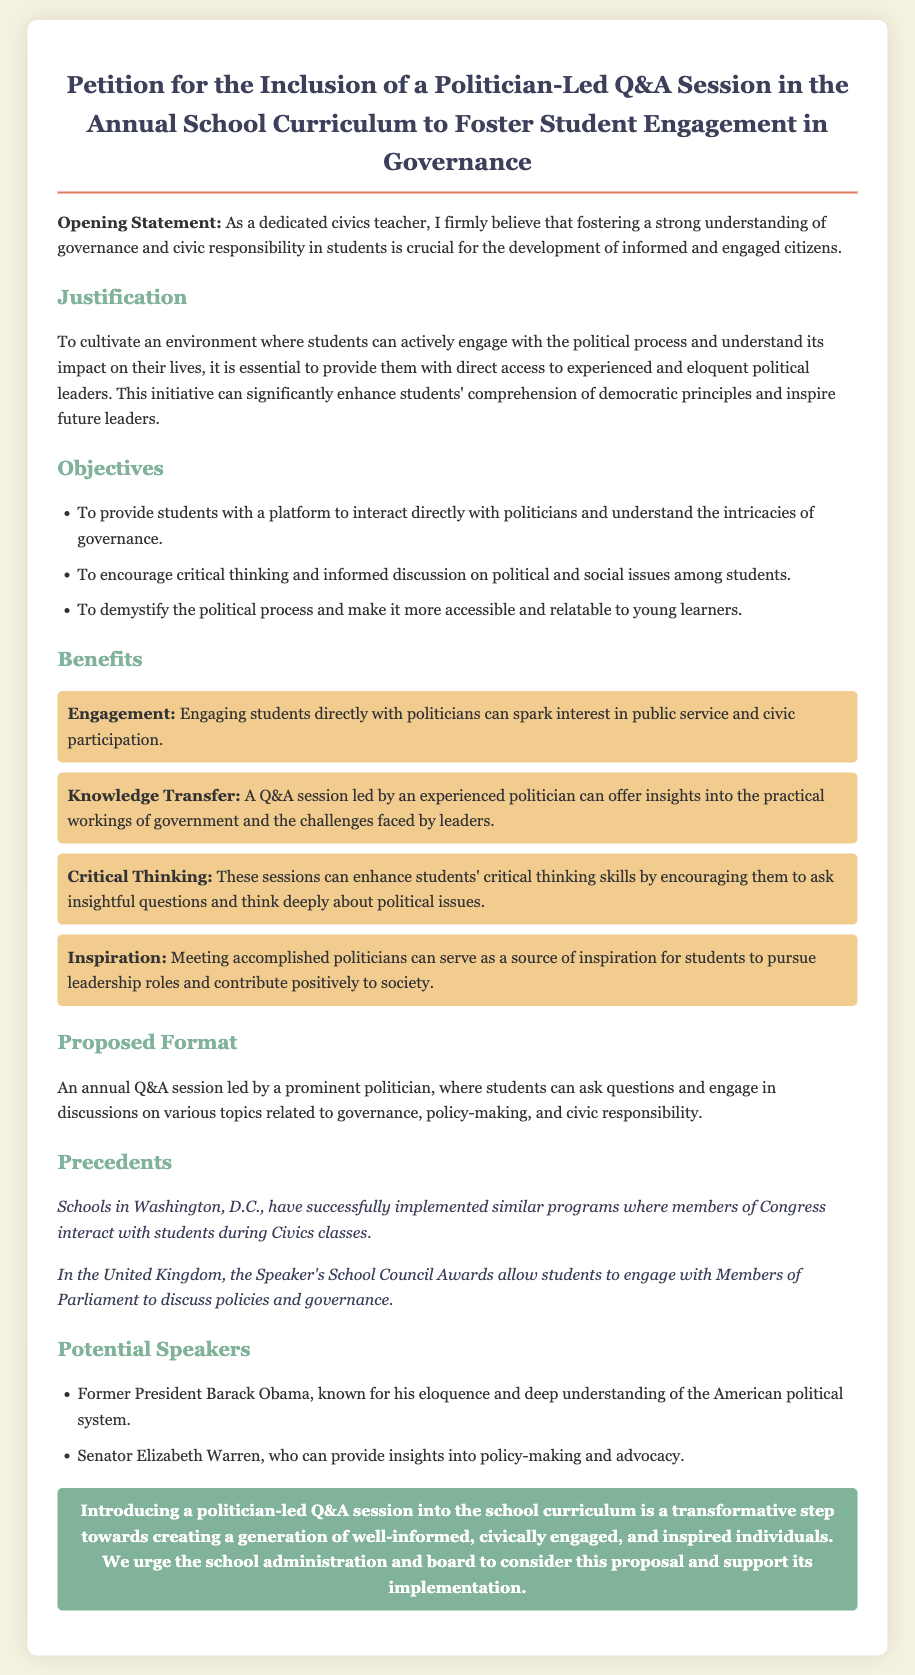what is the title of the petition? The title of the petition is stated at the top of the document.
Answer: Petition for the Inclusion of a Politician-Led Q&A Session in the Annual School Curriculum to Foster Student Engagement in Governance who is the intended speaker for the Q&A session? The document lists potential speakers for the session under the "Potential Speakers" section.
Answer: Former President Barack Obama what is one objective of the petition? The document lists several objectives in the "Objectives" section.
Answer: To provide students with a platform to interact directly with politicians and understand the intricacies of governance name one benefit mentioned in the petition. Several benefits are outlined under the "Benefits" section of the document.
Answer: Engagement where have similar programs been implemented? The precedents section mentions locations where similar programs exist.
Answer: Washington, D.C how many potential speakers are listed in the document? The document lists the potential speakers under a specific section.
Answer: 2 what does the conclusion urge the school to do? The conclusion summarizes the main request of the petition document.
Answer: Support its implementation what does the petition emphasize about student engagement? The introduction and various sections of the document highlight the importance of engagement.
Answer: Fostering a strong understanding of governance and civic responsibility 